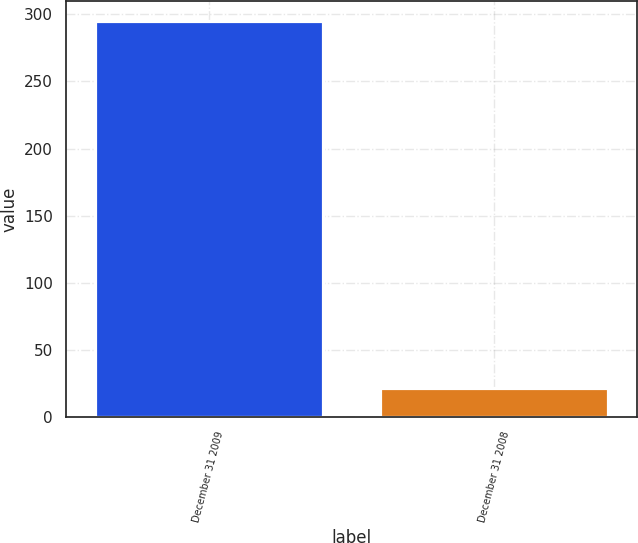Convert chart. <chart><loc_0><loc_0><loc_500><loc_500><bar_chart><fcel>December 31 2009<fcel>December 31 2008<nl><fcel>295<fcel>22<nl></chart> 